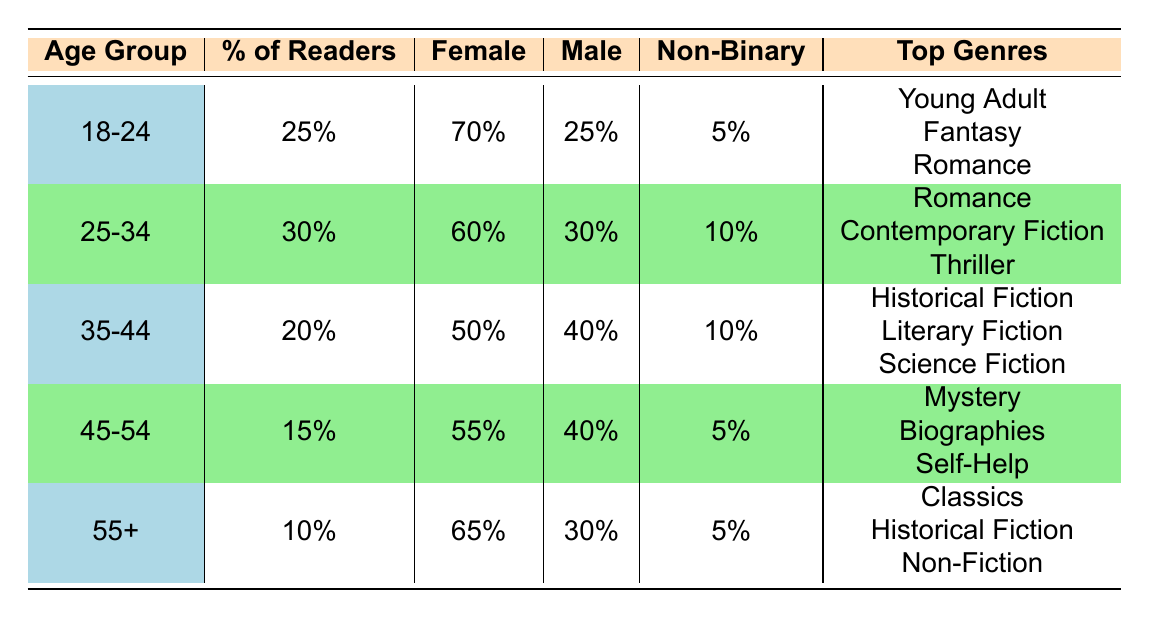What percentage of readers belong to the age group 25-34? The table shows that the percentage of readers in the age group 25-34 is listed directly under the "% of Readers" column, which states 30%.
Answer: 30% What is the gender distribution for the 18-24 age group? The table lists the gender distribution for the 18-24 age group in separate columns: Female is 70%, Male is 25%, and Non-Binary is 5%.
Answer: Female: 70%, Male: 25%, Non-Binary: 5% Which age group has the highest percentage of readers? By examining the "% of Readers" column, the age group with the highest percentage is 25-34, which is 30%.
Answer: 25-34 Do more females or males read Stephanie Rendón's works in the 35-44 age group? In the 35-44 age group, females comprise 50% while males make up 40%. Since 50% > 40%, more females read her works in this age group.
Answer: More females What percentage of the total fanbase is made up of readers aged 45-54 or older? To find this, add the percentages of readers in the 45-54 age group (15%) and the 55+ age group (10%). Thus, 15% + 10% = 25%.
Answer: 25% What are the top three favorite genres of readers aged 55 and older? The table lists the favorite genres for the 55+ age group: Classics, Historical Fiction, and Non-Fiction. These are the top three genres for this age group.
Answer: Classics, Historical Fiction, Non-Fiction Is the percentage of non-binary readers in the 25-34 age group higher than in the 45-54 age group? The non-binary percentage for the 25-34 age group is 10%, while for the 45-54 age group, it is 5%. Since 10% > 5%, it is true that the 25-34 age group has a higher percentage.
Answer: Yes How many percentage points separate the age groups 18-24 and 35-44? The percentage for the 18-24 age group is 25%, and for the 35-44 age group, it is 20%. The difference is calculated as 25% - 20% = 5 percentage points.
Answer: 5 What age group has the highest representation of non-binary readers? The non-binary representation is highest in the 25-34 age group at 10%, compared to 5% in the other age groups.
Answer: 25-34 Determine the average percentage of female readers across all age groups. To calculate this, add the female percentages for each age group: (70% + 60% + 50% + 55% + 65%) = 400%. Then divide by 5 age groups: 400% / 5 = 80%.
Answer: 80% In which geographic locations are the readers aged 45-54 primarily located? The table lists the geographic locations for the 45-54 age group as Michigan, Arizona, and Massachusetts, indicating these are their primary locations.
Answer: Michigan, Arizona, Massachusetts 